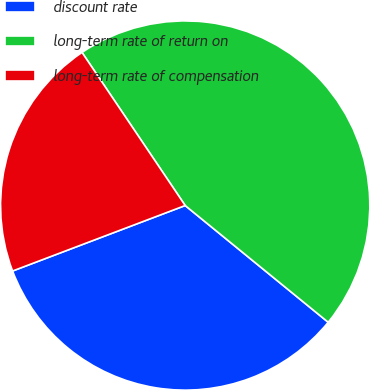Convert chart to OTSL. <chart><loc_0><loc_0><loc_500><loc_500><pie_chart><fcel>discount rate<fcel>long-term rate of return on<fcel>long-term rate of compensation<nl><fcel>33.33%<fcel>45.33%<fcel>21.33%<nl></chart> 